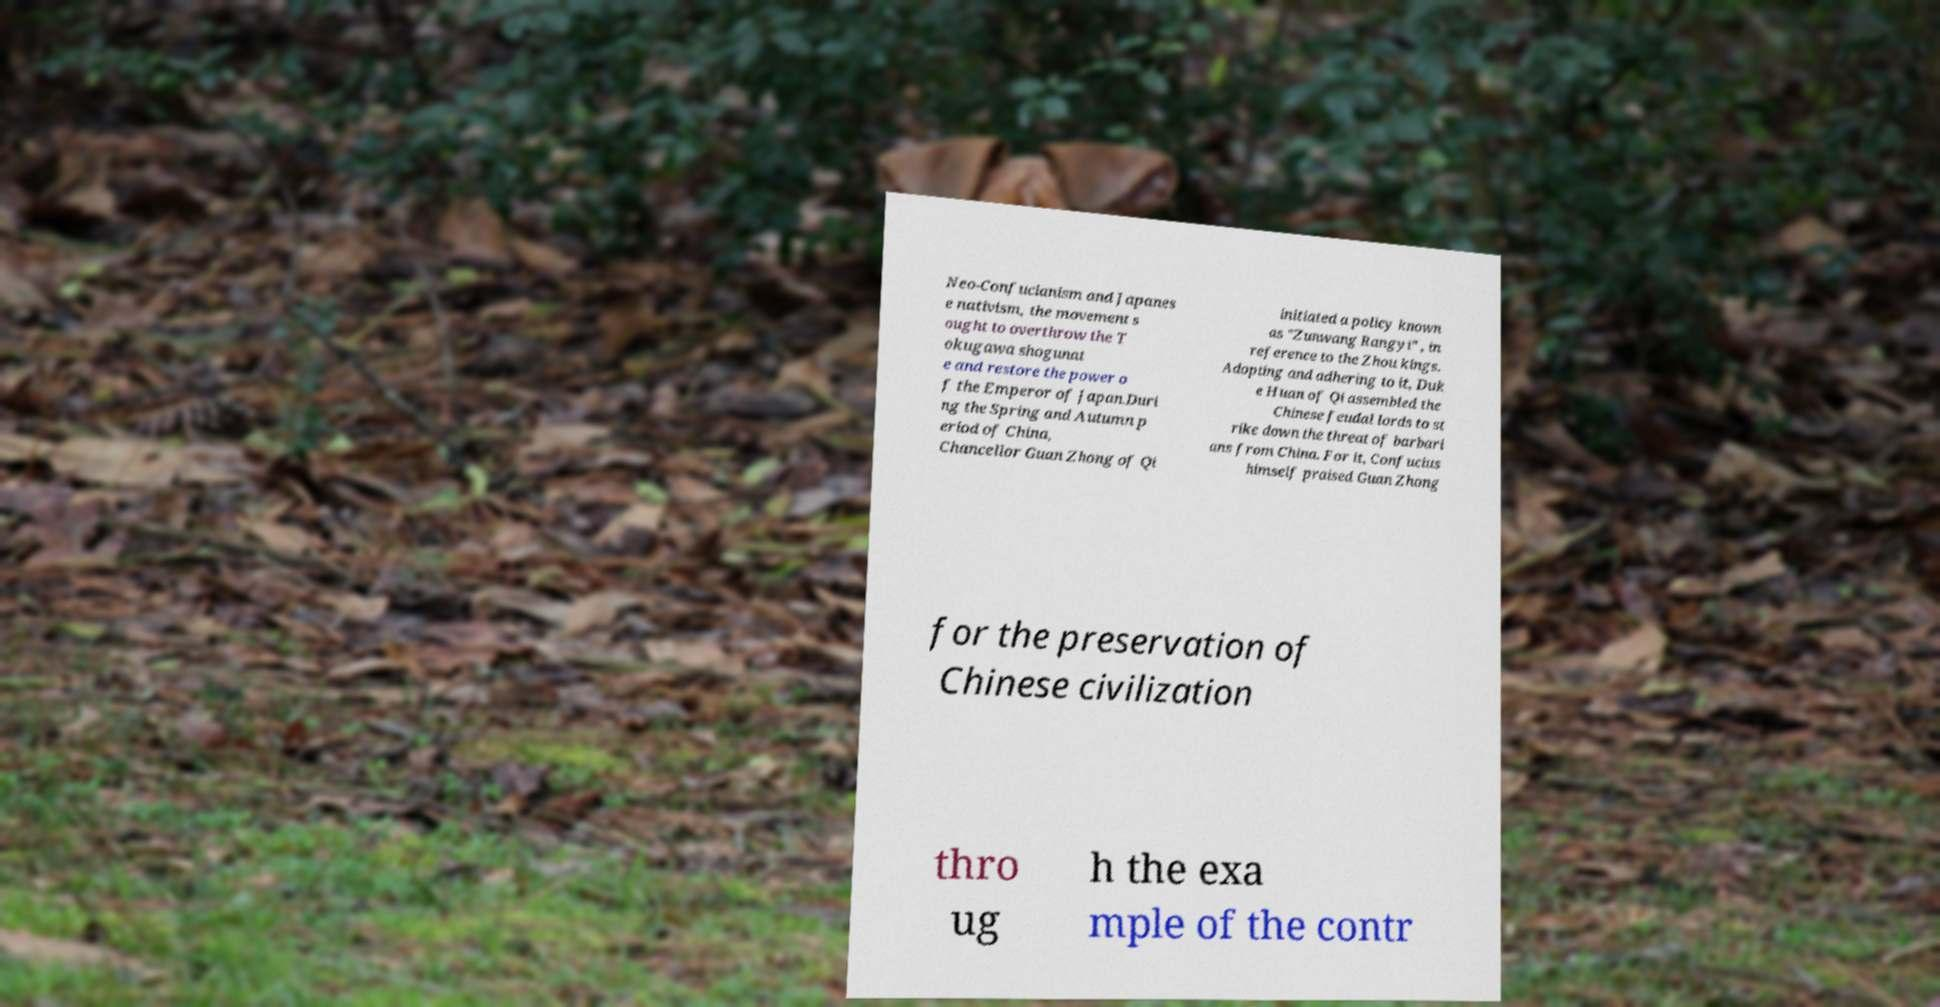Could you assist in decoding the text presented in this image and type it out clearly? Neo-Confucianism and Japanes e nativism, the movement s ought to overthrow the T okugawa shogunat e and restore the power o f the Emperor of Japan.Duri ng the Spring and Autumn p eriod of China, Chancellor Guan Zhong of Qi initiated a policy known as "Zunwang Rangyi" , in reference to the Zhou kings. Adopting and adhering to it, Duk e Huan of Qi assembled the Chinese feudal lords to st rike down the threat of barbari ans from China. For it, Confucius himself praised Guan Zhong for the preservation of Chinese civilization thro ug h the exa mple of the contr 